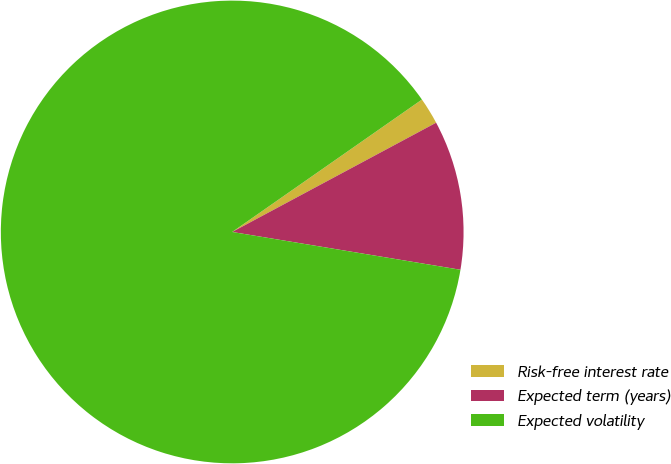Convert chart to OTSL. <chart><loc_0><loc_0><loc_500><loc_500><pie_chart><fcel>Risk-free interest rate<fcel>Expected term (years)<fcel>Expected volatility<nl><fcel>1.87%<fcel>10.44%<fcel>87.69%<nl></chart> 